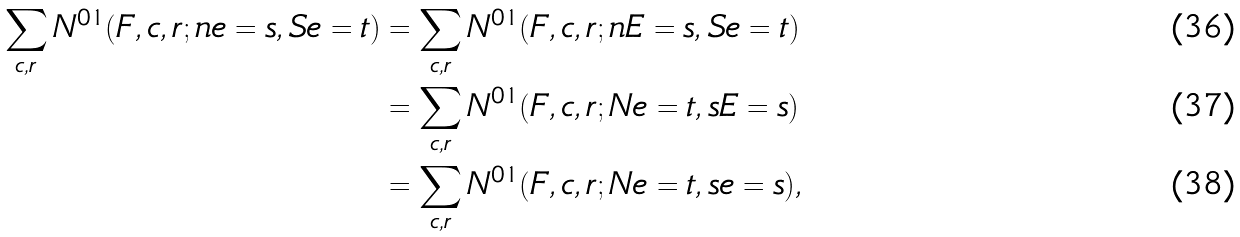<formula> <loc_0><loc_0><loc_500><loc_500>\sum _ { c , r } N ^ { 0 1 } ( F , c , r ; n e = s , S e = t ) & = \sum _ { c , r } N ^ { 0 1 } ( F , c , r ; n E = s , S e = t ) \\ & = \sum _ { c , r } N ^ { 0 1 } ( F , c , r ; N e = t , s E = s ) \\ & = \sum _ { c , r } N ^ { 0 1 } ( F , c , r ; N e = t , s e = s ) ,</formula> 